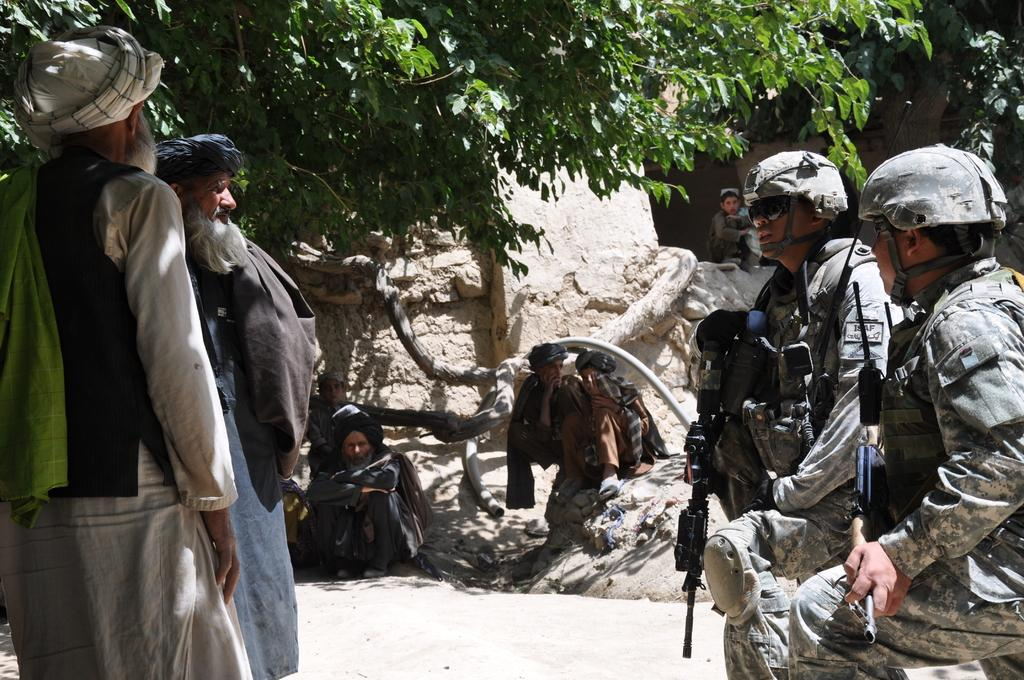How many people are in the image? There are people in the image. What are two of the people holding? Two people are holding guns. What protective gear are the two people with guns wearing? The two people with guns are wearing helmets. What type of natural environment can be seen in the image? There are trees visible in the image. What type of structure is present in the image? There is a wall in the image. What type of paste is being used to decorate the cabbage in the image? There is no paste or cabbage present in the image. What type of car can be seen driving through the wall in the image? There is no car or wall being driven through in the image. 